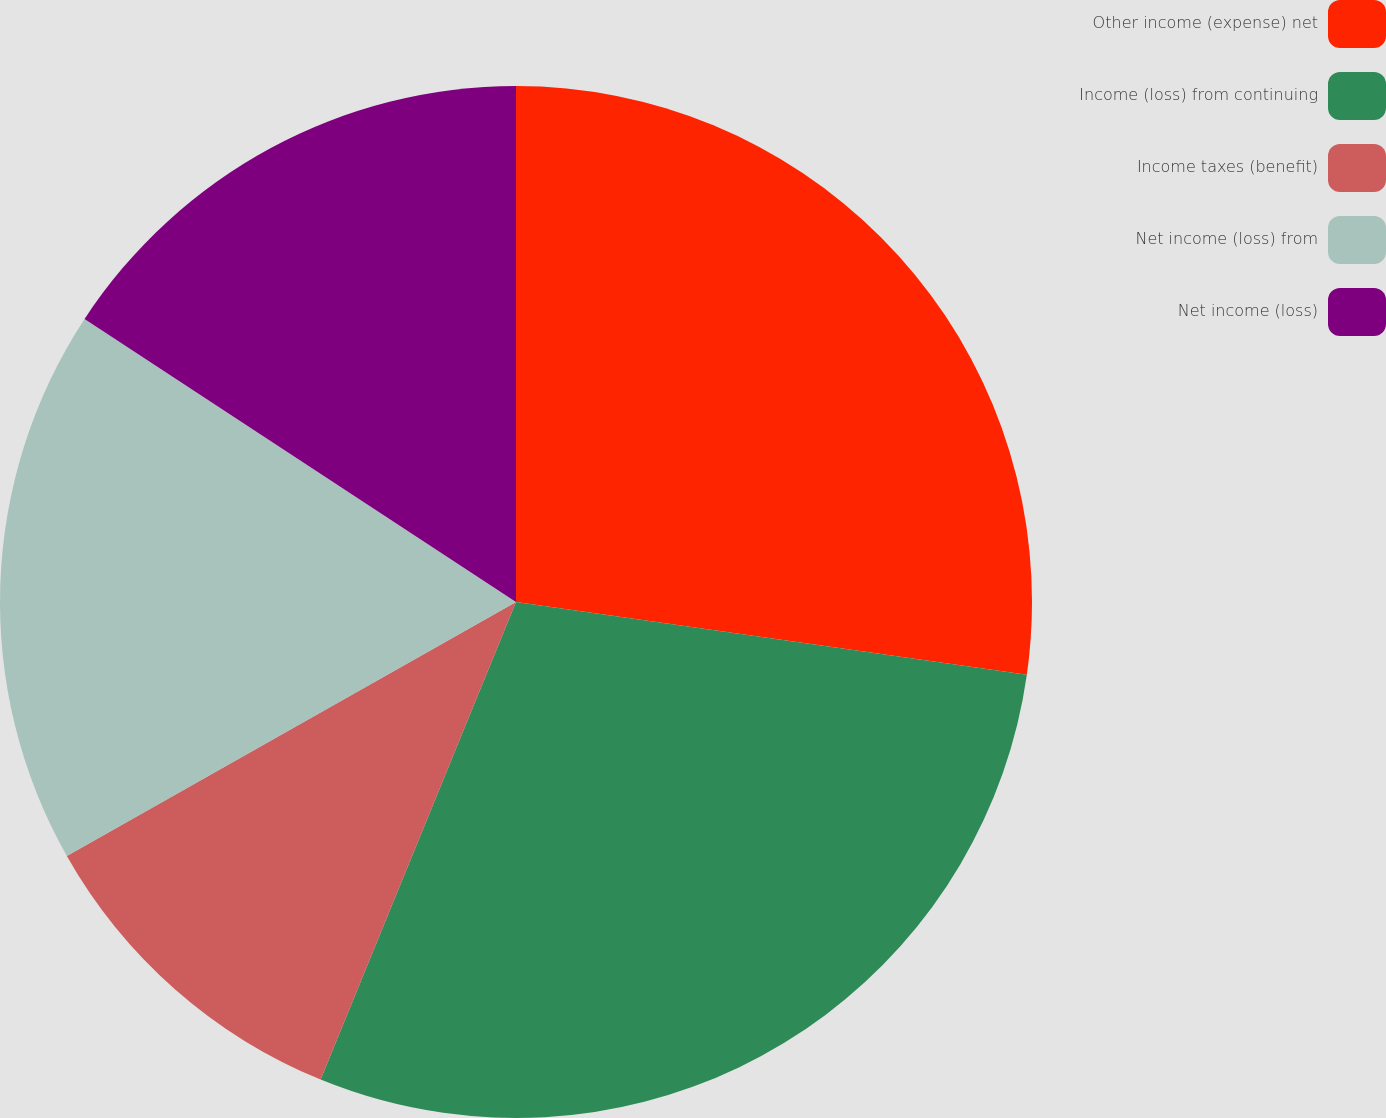Convert chart to OTSL. <chart><loc_0><loc_0><loc_500><loc_500><pie_chart><fcel>Other income (expense) net<fcel>Income (loss) from continuing<fcel>Income taxes (benefit)<fcel>Net income (loss) from<fcel>Net income (loss)<nl><fcel>27.25%<fcel>28.93%<fcel>10.63%<fcel>17.43%<fcel>15.76%<nl></chart> 